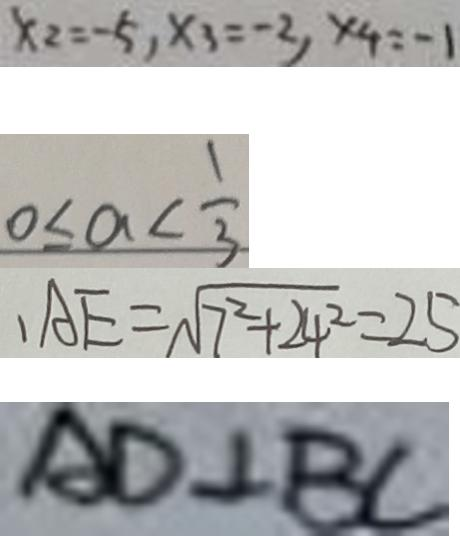<formula> <loc_0><loc_0><loc_500><loc_500>x _ { 2 } = - 5 , x _ { 3 } = - 2 , x _ { 4 } = - 1 
 0 \leq a < \frac { 1 } { 3 } 
 A E = \sqrt { 7 ^ { 2 } + 2 4 ^ { 2 } } = 2 5 
 A D \bot B C</formula> 